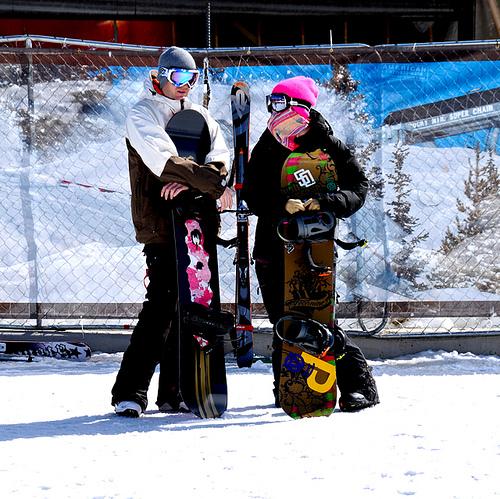In what sport are they prepared to participate?
Be succinct. Snowboarding. This picture was taken well after 10:00 pm?
Be succinct. No. What color is the hat of the person on the right?
Concise answer only. Pink. 